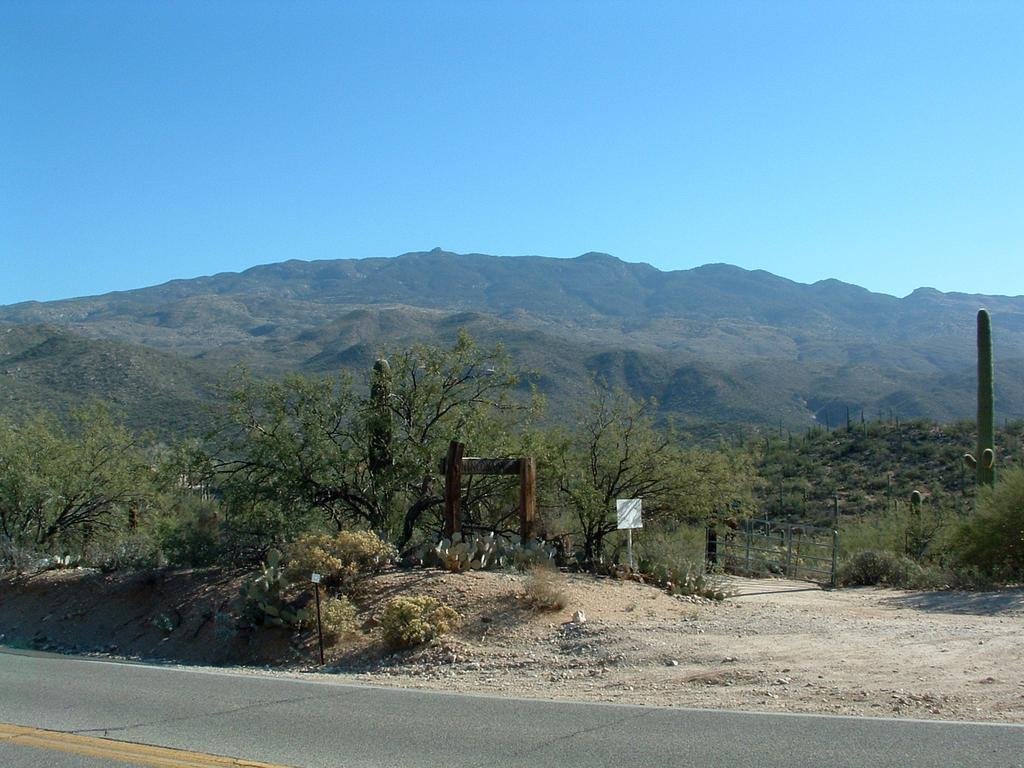What type of pathway is visible in the image? There is a road in the image. What structures can be seen alongside the road? There are poles in the image. What is the purpose of the board in the image? The purpose of the board is not specified, but it is present in the image. What type of artwork is visible in the image? There are wooden arts in the image. What type of natural vegetation is present in the image? There are trees in the image. What type of geographical feature can be seen in the background of the image? There are hills in the image. What is the color of the sky in the background of the image? The blue sky is visible in the background of the image. Can you see any signs of a kiss between the trees in the image? There is no indication of a kiss or any romantic interaction between the trees in the image. Is there any evidence of pain or injury in the image? There is no indication of pain or injury in the image. 